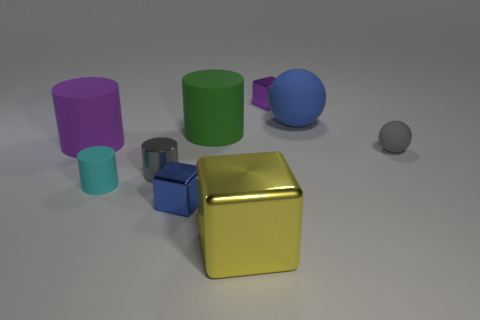Could you speculate on the purpose of this image? Is it educational, artistic, or something else? This image seems to have an illustrative quality that could serve multiple purposes. It is possibly designed for artistic purposes, to study the interaction of light with different colors and shapes, or as a render test for 3D modeling software. The context isn't provided, but its simplicity and clean composition lend itself to a variety of interpretations. 